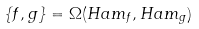Convert formula to latex. <formula><loc_0><loc_0><loc_500><loc_500>\{ f , g \} = \Omega ( H a m _ { f } , H a m _ { g } )</formula> 